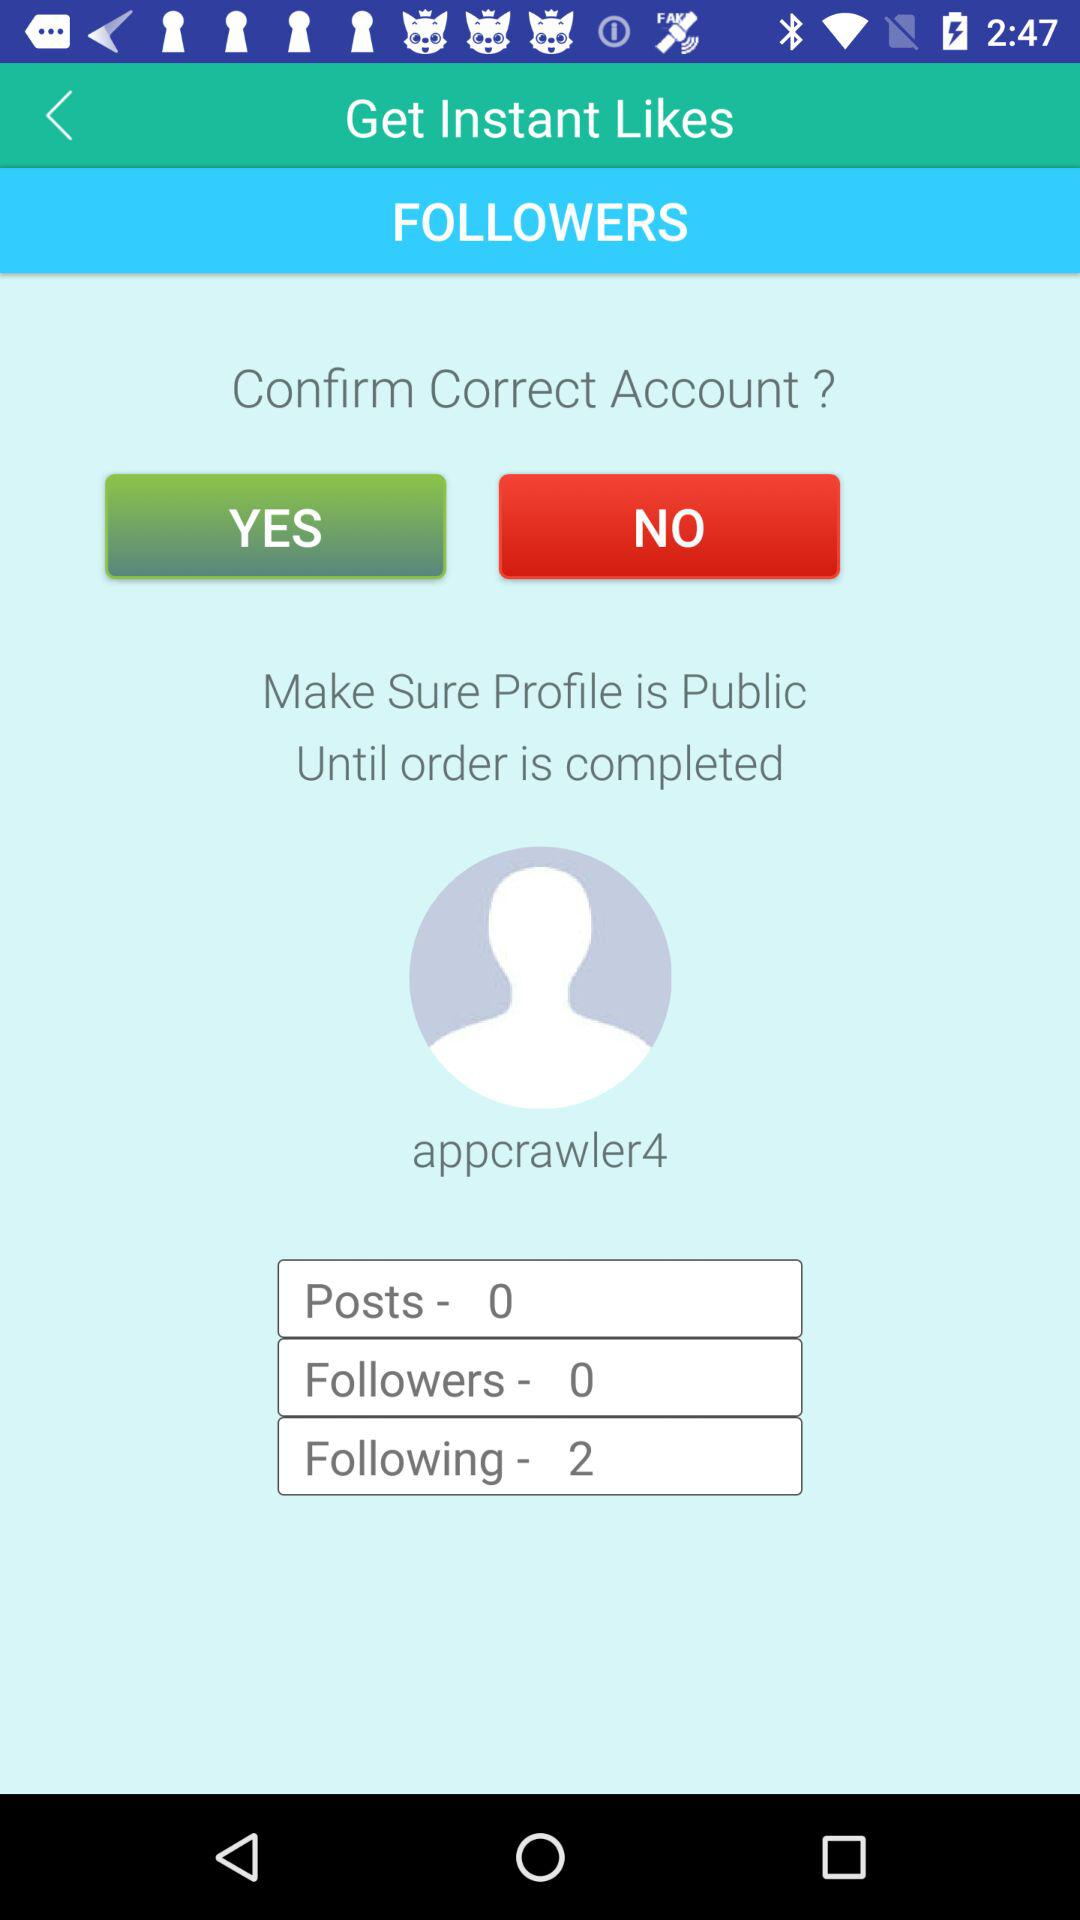How many people are followed by a user? There are 2 people followed by a user,. 